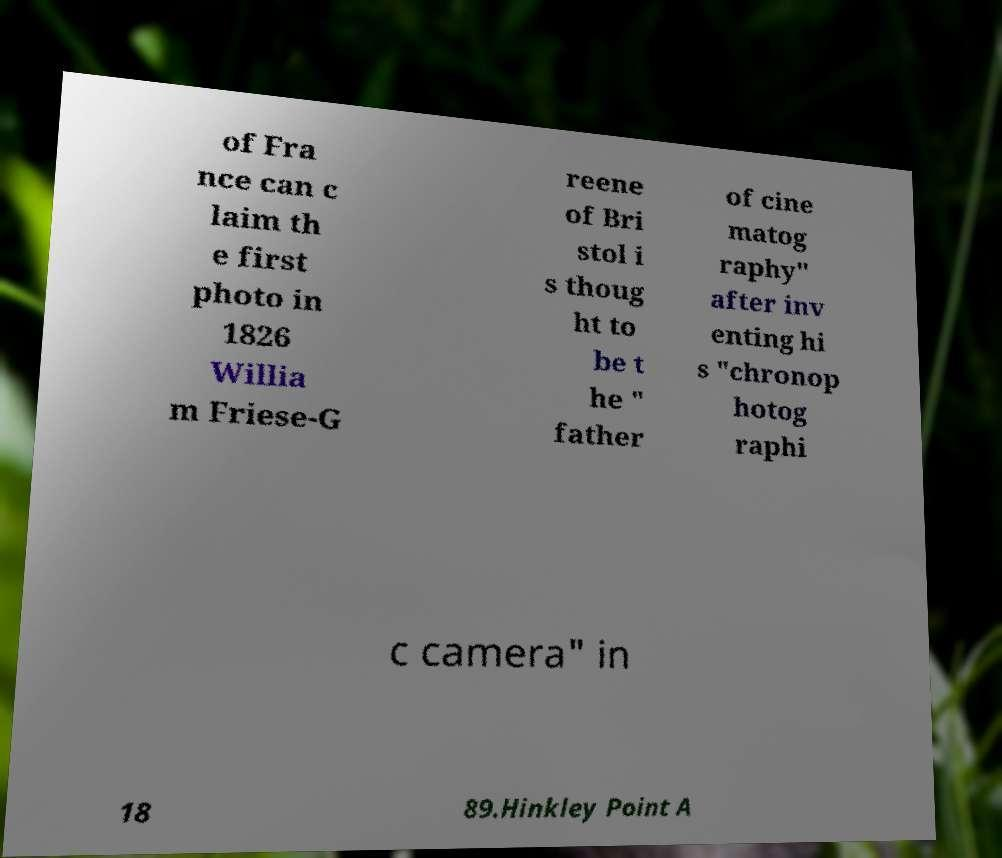I need the written content from this picture converted into text. Can you do that? of Fra nce can c laim th e first photo in 1826 Willia m Friese-G reene of Bri stol i s thoug ht to be t he " father of cine matog raphy" after inv enting hi s "chronop hotog raphi c camera" in 18 89.Hinkley Point A 